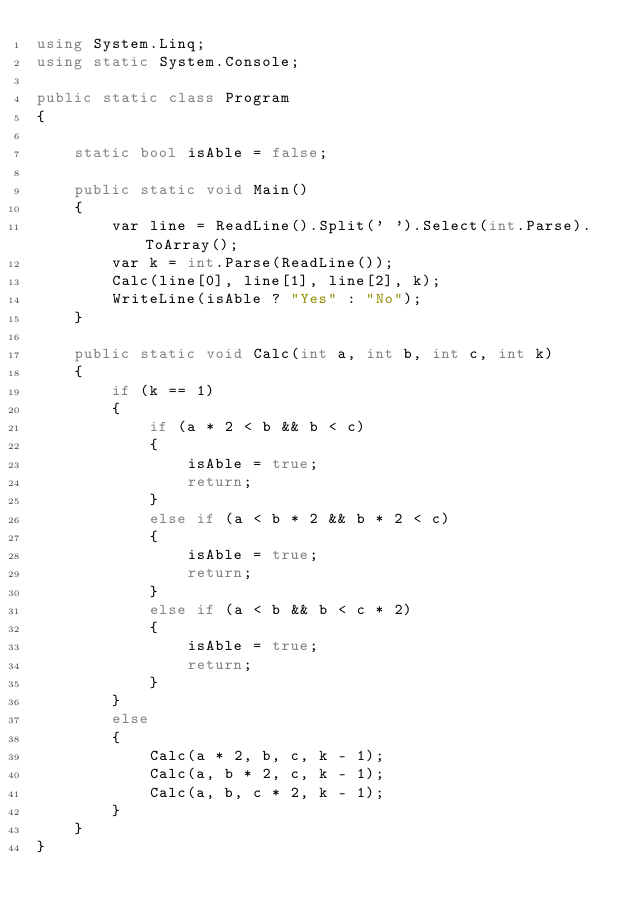<code> <loc_0><loc_0><loc_500><loc_500><_C#_>using System.Linq;
using static System.Console;

public static class Program
{

    static bool isAble = false;

    public static void Main()
    {
        var line = ReadLine().Split(' ').Select(int.Parse).ToArray();
        var k = int.Parse(ReadLine());
        Calc(line[0], line[1], line[2], k);
        WriteLine(isAble ? "Yes" : "No");
    }

    public static void Calc(int a, int b, int c, int k)
    {
        if (k == 1)
        {
            if (a * 2 < b && b < c)
            {
                isAble = true;
                return;
            }
            else if (a < b * 2 && b * 2 < c)
            {
                isAble = true;
                return;
            }
            else if (a < b && b < c * 2)
            {
                isAble = true;
                return;
            }
        }
        else
        {
            Calc(a * 2, b, c, k - 1);
            Calc(a, b * 2, c, k - 1);
            Calc(a, b, c * 2, k - 1);
        }
    }
}</code> 